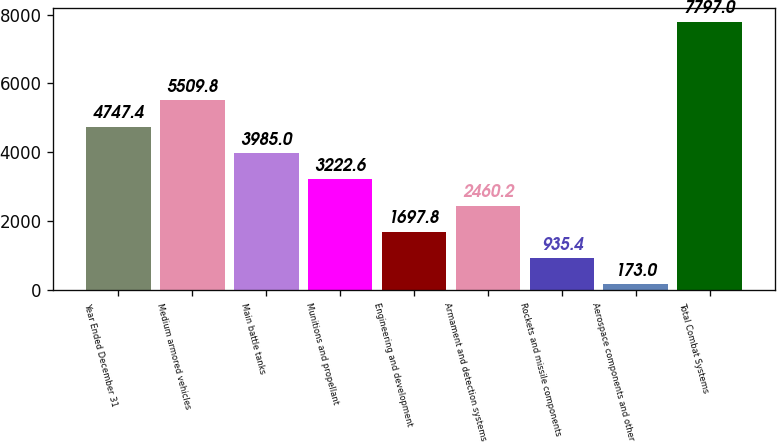Convert chart to OTSL. <chart><loc_0><loc_0><loc_500><loc_500><bar_chart><fcel>Year Ended December 31<fcel>Medium armored vehicles<fcel>Main battle tanks<fcel>Munitions and propellant<fcel>Engineering and development<fcel>Armament and detection systems<fcel>Rockets and missile components<fcel>Aerospace components and other<fcel>Total Combat Systems<nl><fcel>4747.4<fcel>5509.8<fcel>3985<fcel>3222.6<fcel>1697.8<fcel>2460.2<fcel>935.4<fcel>173<fcel>7797<nl></chart> 